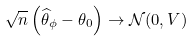<formula> <loc_0><loc_0><loc_500><loc_500>\sqrt { n } \left ( \widehat { \theta } _ { \phi } - \theta _ { 0 } \right ) \rightarrow \mathcal { N } ( 0 , V )</formula> 